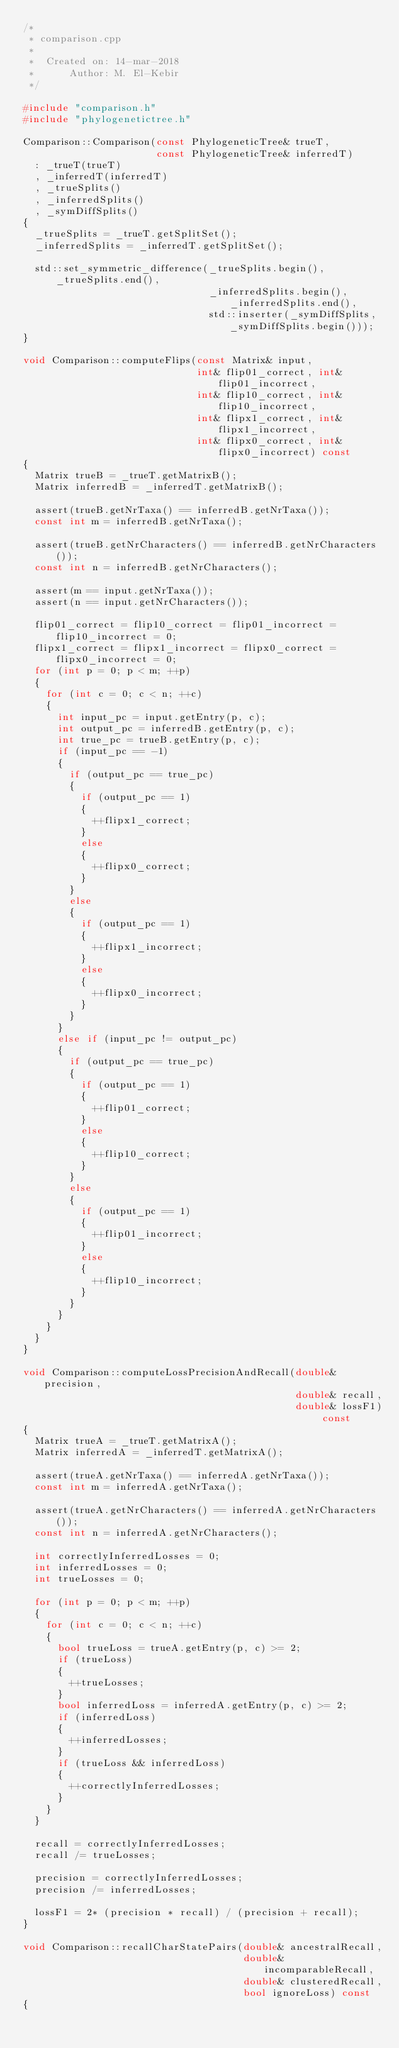<code> <loc_0><loc_0><loc_500><loc_500><_C++_>/*
 * comparison.cpp
 *
 *  Created on: 14-mar-2018
 *      Author: M. El-Kebir
 */

#include "comparison.h"
#include "phylogenetictree.h"

Comparison::Comparison(const PhylogeneticTree& trueT,
                       const PhylogeneticTree& inferredT)
  : _trueT(trueT)
  , _inferredT(inferredT)
  , _trueSplits()
  , _inferredSplits()
  , _symDiffSplits()
{
  _trueSplits = _trueT.getSplitSet();
  _inferredSplits = _inferredT.getSplitSet();
  
  std::set_symmetric_difference(_trueSplits.begin(), _trueSplits.end(),
                                _inferredSplits.begin(), _inferredSplits.end(),
                                std::inserter(_symDiffSplits, _symDiffSplits.begin()));
}

void Comparison::computeFlips(const Matrix& input,
                              int& flip01_correct, int& flip01_incorrect,
                              int& flip10_correct, int& flip10_incorrect,
                              int& flipx1_correct, int& flipx1_incorrect,
                              int& flipx0_correct, int& flipx0_incorrect) const
{
  Matrix trueB = _trueT.getMatrixB();
  Matrix inferredB = _inferredT.getMatrixB();
  
  assert(trueB.getNrTaxa() == inferredB.getNrTaxa());
  const int m = inferredB.getNrTaxa();
  
  assert(trueB.getNrCharacters() == inferredB.getNrCharacters());
  const int n = inferredB.getNrCharacters();
  
  assert(m == input.getNrTaxa());
  assert(n == input.getNrCharacters());
  
  flip01_correct = flip10_correct = flip01_incorrect = flip10_incorrect = 0;
  flipx1_correct = flipx1_incorrect = flipx0_correct = flipx0_incorrect = 0;
  for (int p = 0; p < m; ++p)
  {
    for (int c = 0; c < n; ++c)
    {
      int input_pc = input.getEntry(p, c);
      int output_pc = inferredB.getEntry(p, c);
      int true_pc = trueB.getEntry(p, c);
      if (input_pc == -1)
      {
        if (output_pc == true_pc)
        {
          if (output_pc == 1)
          {
            ++flipx1_correct;
          }
          else
          {
            ++flipx0_correct;
          }
        }
        else
        {
          if (output_pc == 1)
          {
            ++flipx1_incorrect;
          }
          else
          {
            ++flipx0_incorrect;
          }
        }
      }
      else if (input_pc != output_pc)
      {
        if (output_pc == true_pc)
        {
          if (output_pc == 1)
          {
            ++flip01_correct;
          }
          else
          {
            ++flip10_correct;
          }
        }
        else
        {
          if (output_pc == 1)
          {
            ++flip01_incorrect;
          }
          else
          {
            ++flip10_incorrect;
          }
        }
      }
    }
  }
}

void Comparison::computeLossPrecisionAndRecall(double& precision,
                                               double& recall,
                                               double& lossF1) const
{
  Matrix trueA = _trueT.getMatrixA();
  Matrix inferredA = _inferredT.getMatrixA();
  
  assert(trueA.getNrTaxa() == inferredA.getNrTaxa());
  const int m = inferredA.getNrTaxa();
  
  assert(trueA.getNrCharacters() == inferredA.getNrCharacters());
  const int n = inferredA.getNrCharacters();
  
  int correctlyInferredLosses = 0;
  int inferredLosses = 0;
  int trueLosses = 0;
  
  for (int p = 0; p < m; ++p)
  {
    for (int c = 0; c < n; ++c)
    {
      bool trueLoss = trueA.getEntry(p, c) >= 2;
      if (trueLoss)
      {
        ++trueLosses;
      }
      bool inferredLoss = inferredA.getEntry(p, c) >= 2;
      if (inferredLoss)
      {
        ++inferredLosses;
      }
      if (trueLoss && inferredLoss)
      {
        ++correctlyInferredLosses;
      }
    }
  }
  
  recall = correctlyInferredLosses;
  recall /= trueLosses;
   
  precision = correctlyInferredLosses;
  precision /= inferredLosses;
  
  lossF1 = 2* (precision * recall) / (precision + recall);
}

void Comparison::recallCharStatePairs(double& ancestralRecall,
                                      double& incomparableRecall,
                                      double& clusteredRecall,
                                      bool ignoreLoss) const
{</code> 